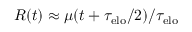<formula> <loc_0><loc_0><loc_500><loc_500>R ( t ) \approx \mu ( t + \tau _ { e l o } / 2 ) / \tau _ { e l o }</formula> 